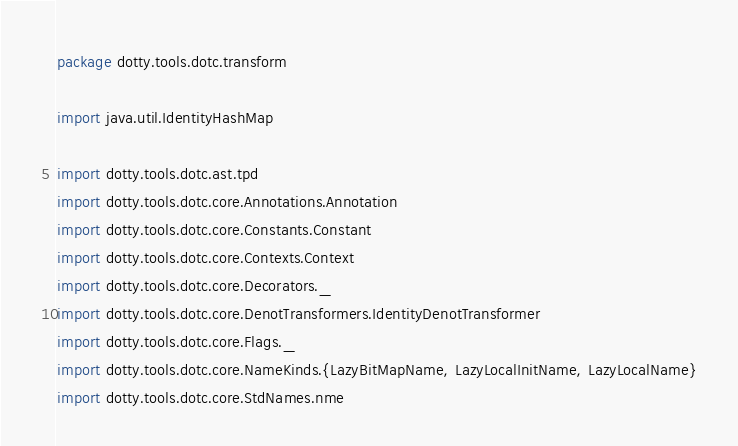Convert code to text. <code><loc_0><loc_0><loc_500><loc_500><_Scala_>package dotty.tools.dotc.transform

import java.util.IdentityHashMap

import dotty.tools.dotc.ast.tpd
import dotty.tools.dotc.core.Annotations.Annotation
import dotty.tools.dotc.core.Constants.Constant
import dotty.tools.dotc.core.Contexts.Context
import dotty.tools.dotc.core.Decorators._
import dotty.tools.dotc.core.DenotTransformers.IdentityDenotTransformer
import dotty.tools.dotc.core.Flags._
import dotty.tools.dotc.core.NameKinds.{LazyBitMapName, LazyLocalInitName, LazyLocalName}
import dotty.tools.dotc.core.StdNames.nme</code> 